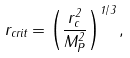<formula> <loc_0><loc_0><loc_500><loc_500>r _ { c r i t } = \left ( \frac { r _ { c } ^ { 2 } } { M _ { P } ^ { 2 } } \right ) ^ { 1 / 3 } ,</formula> 